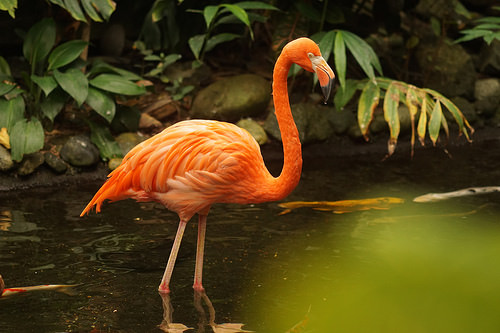<image>
Is the bird above the fish? No. The bird is not positioned above the fish. The vertical arrangement shows a different relationship. 